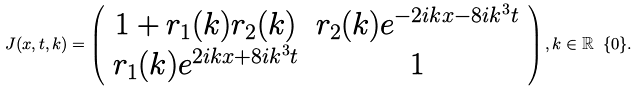<formula> <loc_0><loc_0><loc_500><loc_500>J ( x , t , k ) = \left ( \begin{array} { c c } 1 + r _ { 1 } ( k ) r _ { 2 } ( k ) & r _ { 2 } ( k ) e ^ { - 2 i k x - 8 i k ^ { 3 } t } \\ r _ { 1 } ( k ) e ^ { 2 i k x + 8 i k ^ { 3 } t } & 1 \end{array} \right ) , k \in \mathbb { R } \ \{ 0 \} .</formula> 